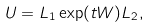<formula> <loc_0><loc_0><loc_500><loc_500>U = L _ { 1 } \exp ( t W ) L _ { 2 } ,</formula> 